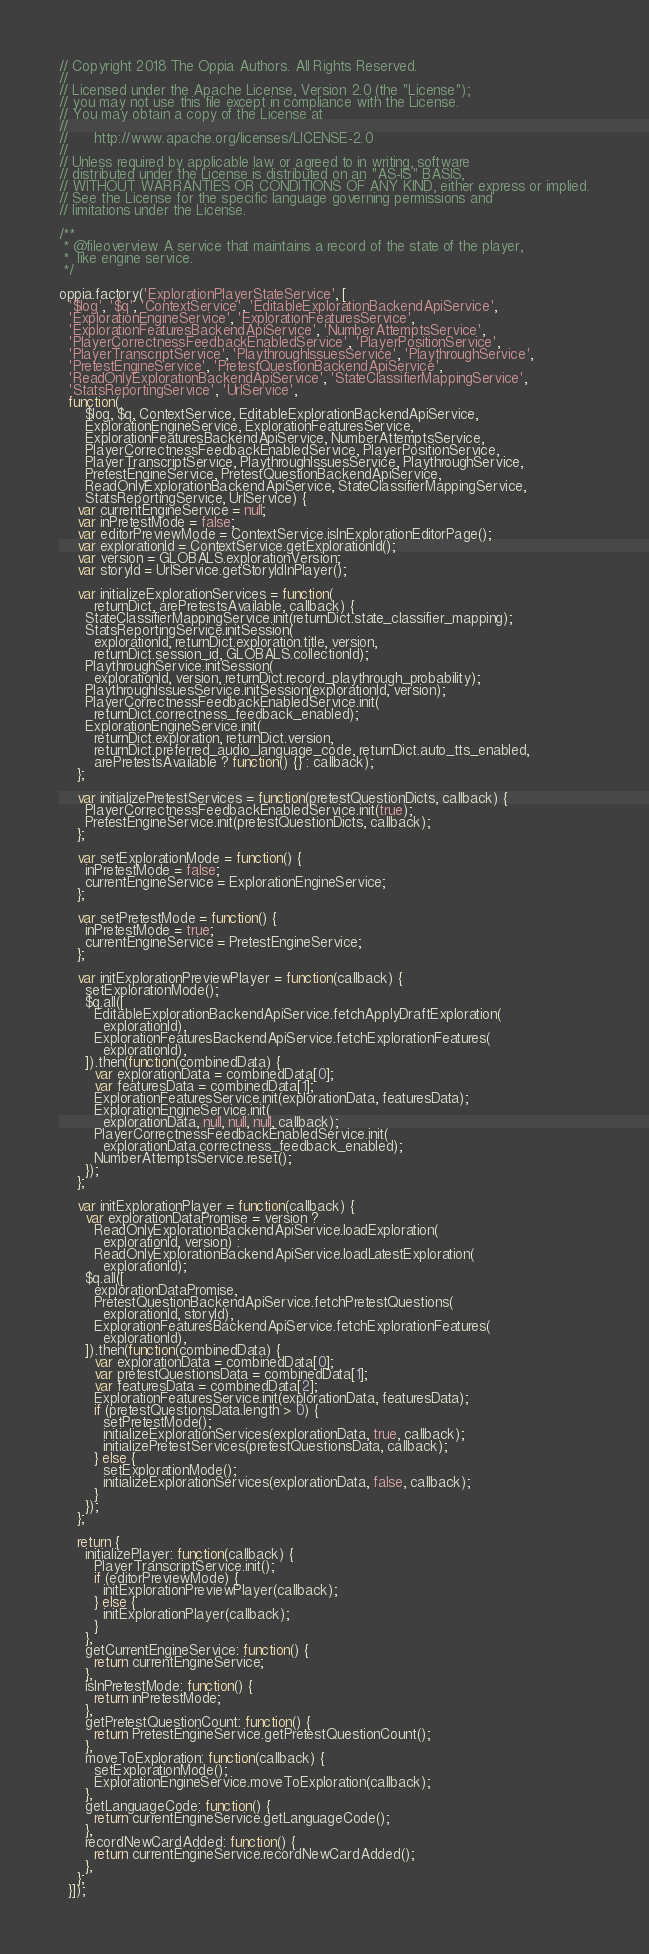Convert code to text. <code><loc_0><loc_0><loc_500><loc_500><_JavaScript_>// Copyright 2018 The Oppia Authors. All Rights Reserved.
//
// Licensed under the Apache License, Version 2.0 (the "License");
// you may not use this file except in compliance with the License.
// You may obtain a copy of the License at
//
//      http://www.apache.org/licenses/LICENSE-2.0
//
// Unless required by applicable law or agreed to in writing, software
// distributed under the License is distributed on an "AS-IS" BASIS,
// WITHOUT WARRANTIES OR CONDITIONS OF ANY KIND, either express or implied.
// See the License for the specific language governing permissions and
// limitations under the License.

/**
 * @fileoverview A service that maintains a record of the state of the player,
 *  like engine service.
 */

oppia.factory('ExplorationPlayerStateService', [
  '$log', '$q', 'ContextService', 'EditableExplorationBackendApiService',
  'ExplorationEngineService', 'ExplorationFeaturesService',
  'ExplorationFeaturesBackendApiService', 'NumberAttemptsService',
  'PlayerCorrectnessFeedbackEnabledService', 'PlayerPositionService',
  'PlayerTranscriptService', 'PlaythroughIssuesService', 'PlaythroughService',
  'PretestEngineService', 'PretestQuestionBackendApiService',
  'ReadOnlyExplorationBackendApiService', 'StateClassifierMappingService',
  'StatsReportingService', 'UrlService',
  function(
      $log, $q, ContextService, EditableExplorationBackendApiService,
      ExplorationEngineService, ExplorationFeaturesService,
      ExplorationFeaturesBackendApiService, NumberAttemptsService,
      PlayerCorrectnessFeedbackEnabledService, PlayerPositionService,
      PlayerTranscriptService, PlaythroughIssuesService, PlaythroughService,
      PretestEngineService, PretestQuestionBackendApiService,
      ReadOnlyExplorationBackendApiService, StateClassifierMappingService,
      StatsReportingService, UrlService) {
    var currentEngineService = null;
    var inPretestMode = false;
    var editorPreviewMode = ContextService.isInExplorationEditorPage();
    var explorationId = ContextService.getExplorationId();
    var version = GLOBALS.explorationVersion;
    var storyId = UrlService.getStoryIdInPlayer();

    var initializeExplorationServices = function(
        returnDict, arePretestsAvailable, callback) {
      StateClassifierMappingService.init(returnDict.state_classifier_mapping);
      StatsReportingService.initSession(
        explorationId, returnDict.exploration.title, version,
        returnDict.session_id, GLOBALS.collectionId);
      PlaythroughService.initSession(
        explorationId, version, returnDict.record_playthrough_probability);
      PlaythroughIssuesService.initSession(explorationId, version);
      PlayerCorrectnessFeedbackEnabledService.init(
        returnDict.correctness_feedback_enabled);
      ExplorationEngineService.init(
        returnDict.exploration, returnDict.version,
        returnDict.preferred_audio_language_code, returnDict.auto_tts_enabled,
        arePretestsAvailable ? function() {} : callback);
    };

    var initializePretestServices = function(pretestQuestionDicts, callback) {
      PlayerCorrectnessFeedbackEnabledService.init(true);
      PretestEngineService.init(pretestQuestionDicts, callback);
    };

    var setExplorationMode = function() {
      inPretestMode = false;
      currentEngineService = ExplorationEngineService;
    };

    var setPretestMode = function() {
      inPretestMode = true;
      currentEngineService = PretestEngineService;
    };

    var initExplorationPreviewPlayer = function(callback) {
      setExplorationMode();
      $q.all([
        EditableExplorationBackendApiService.fetchApplyDraftExploration(
          explorationId),
        ExplorationFeaturesBackendApiService.fetchExplorationFeatures(
          explorationId),
      ]).then(function(combinedData) {
        var explorationData = combinedData[0];
        var featuresData = combinedData[1];
        ExplorationFeaturesService.init(explorationData, featuresData);
        ExplorationEngineService.init(
          explorationData, null, null, null, callback);
        PlayerCorrectnessFeedbackEnabledService.init(
          explorationData.correctness_feedback_enabled);
        NumberAttemptsService.reset();
      });
    };

    var initExplorationPlayer = function(callback) {
      var explorationDataPromise = version ?
        ReadOnlyExplorationBackendApiService.loadExploration(
          explorationId, version) :
        ReadOnlyExplorationBackendApiService.loadLatestExploration(
          explorationId);
      $q.all([
        explorationDataPromise,
        PretestQuestionBackendApiService.fetchPretestQuestions(
          explorationId, storyId),
        ExplorationFeaturesBackendApiService.fetchExplorationFeatures(
          explorationId),
      ]).then(function(combinedData) {
        var explorationData = combinedData[0];
        var pretestQuestionsData = combinedData[1];
        var featuresData = combinedData[2];
        ExplorationFeaturesService.init(explorationData, featuresData);
        if (pretestQuestionsData.length > 0) {
          setPretestMode();
          initializeExplorationServices(explorationData, true, callback);
          initializePretestServices(pretestQuestionsData, callback);
        } else {
          setExplorationMode();
          initializeExplorationServices(explorationData, false, callback);
        }
      });
    };

    return {
      initializePlayer: function(callback) {
        PlayerTranscriptService.init();
        if (editorPreviewMode) {
          initExplorationPreviewPlayer(callback);
        } else {
          initExplorationPlayer(callback);
        }
      },
      getCurrentEngineService: function() {
        return currentEngineService;
      },
      isInPretestMode: function() {
        return inPretestMode;
      },
      getPretestQuestionCount: function() {
        return PretestEngineService.getPretestQuestionCount();
      },
      moveToExploration: function(callback) {
        setExplorationMode();
        ExplorationEngineService.moveToExploration(callback);
      },
      getLanguageCode: function() {
        return currentEngineService.getLanguageCode();
      },
      recordNewCardAdded: function() {
        return currentEngineService.recordNewCardAdded();
      },
    };
  }]);
</code> 